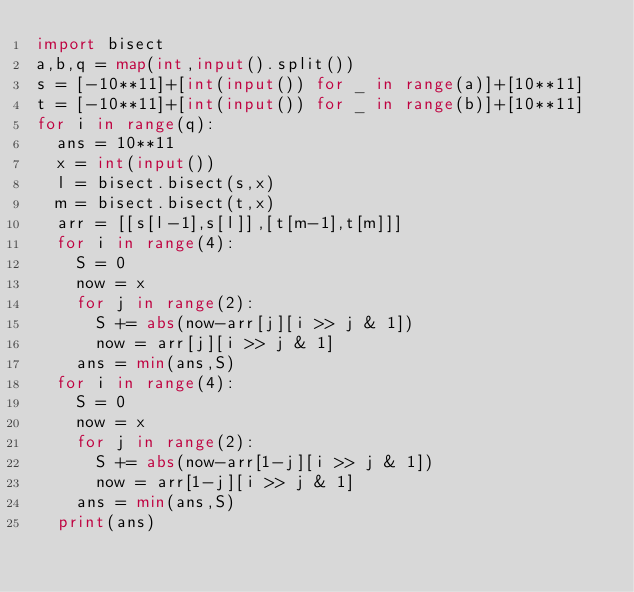<code> <loc_0><loc_0><loc_500><loc_500><_Python_>import bisect
a,b,q = map(int,input().split())
s = [-10**11]+[int(input()) for _ in range(a)]+[10**11]
t = [-10**11]+[int(input()) for _ in range(b)]+[10**11]
for i in range(q):
  ans = 10**11
  x = int(input())
  l = bisect.bisect(s,x)
  m = bisect.bisect(t,x)
  arr = [[s[l-1],s[l]],[t[m-1],t[m]]]
  for i in range(4):
    S = 0
    now = x
    for j in range(2):
      S += abs(now-arr[j][i >> j & 1])
      now = arr[j][i >> j & 1]
    ans = min(ans,S)
  for i in range(4):
    S = 0
    now = x
    for j in range(2):
      S += abs(now-arr[1-j][i >> j & 1])
      now = arr[1-j][i >> j & 1]
    ans = min(ans,S)
  print(ans)
</code> 